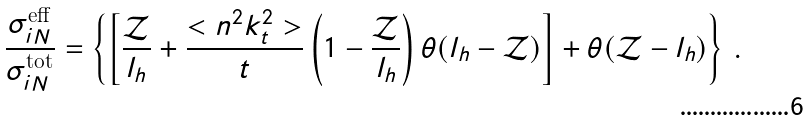<formula> <loc_0><loc_0><loc_500><loc_500>\frac { \sigma ^ { \text {eff} } _ { i N } } { \sigma ^ { \text {tot} } _ { i N } } = \left \{ \left [ \frac { \mathcal { Z } } { l _ { h } } + \frac { < n ^ { 2 } k _ { t } ^ { 2 } > } { t } \left ( 1 - \frac { \mathcal { Z } } { l _ { h } } \right ) \theta ( l _ { h } - \mathcal { Z } ) \right ] + \theta ( \mathcal { Z } - l _ { h } ) \right \} \, .</formula> 